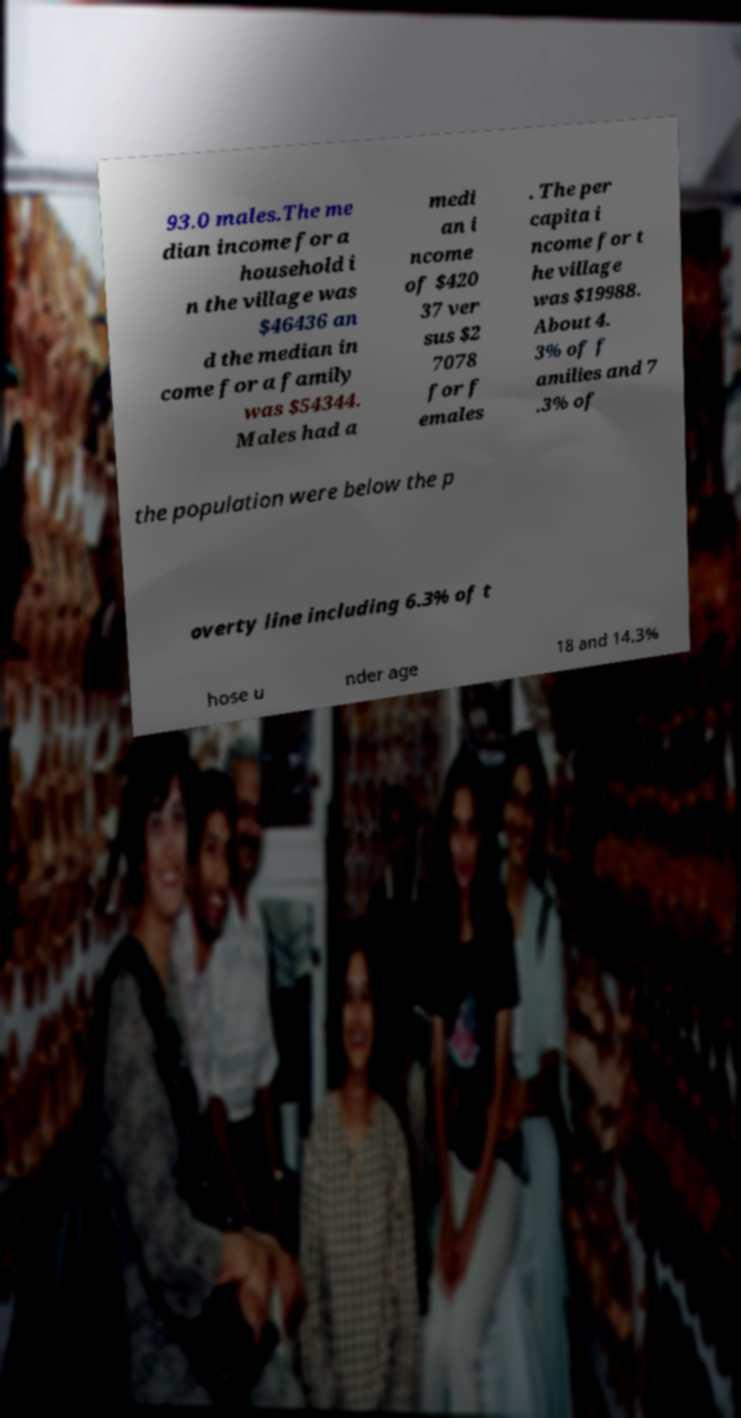For documentation purposes, I need the text within this image transcribed. Could you provide that? 93.0 males.The me dian income for a household i n the village was $46436 an d the median in come for a family was $54344. Males had a medi an i ncome of $420 37 ver sus $2 7078 for f emales . The per capita i ncome for t he village was $19988. About 4. 3% of f amilies and 7 .3% of the population were below the p overty line including 6.3% of t hose u nder age 18 and 14.3% 